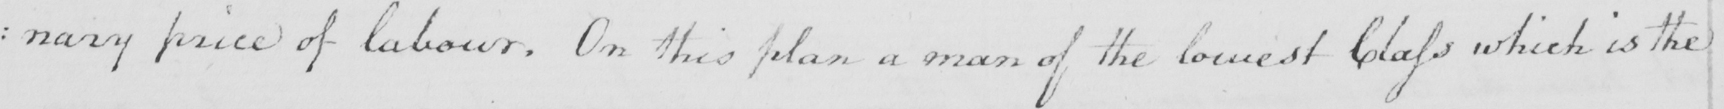Transcribe the text shown in this historical manuscript line. : nary price of labour . On this plan a man of the lowest Class which is the 